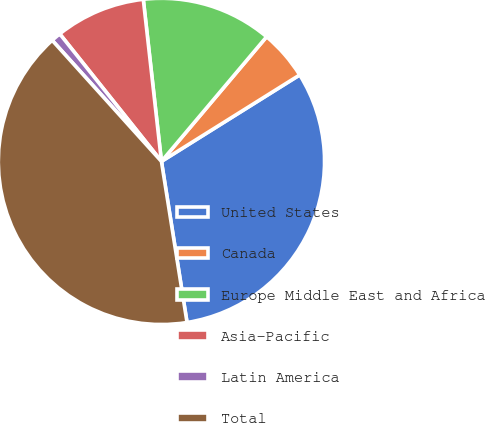Convert chart to OTSL. <chart><loc_0><loc_0><loc_500><loc_500><pie_chart><fcel>United States<fcel>Canada<fcel>Europe Middle East and Africa<fcel>Asia-Pacific<fcel>Latin America<fcel>Total<nl><fcel>31.39%<fcel>4.95%<fcel>12.93%<fcel>8.94%<fcel>0.97%<fcel>40.83%<nl></chart> 